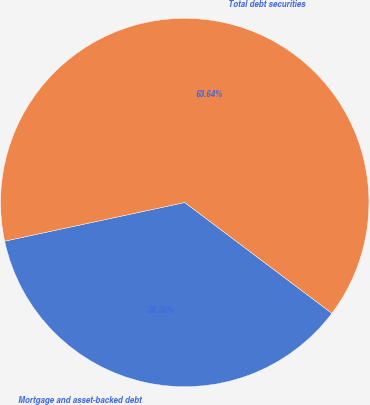<chart> <loc_0><loc_0><loc_500><loc_500><pie_chart><fcel>Mortgage and asset-backed debt<fcel>Total debt securities<nl><fcel>36.36%<fcel>63.64%<nl></chart> 